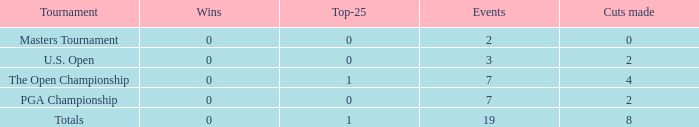What is the complete count of cuts made in competitions with 2 events? 1.0. 